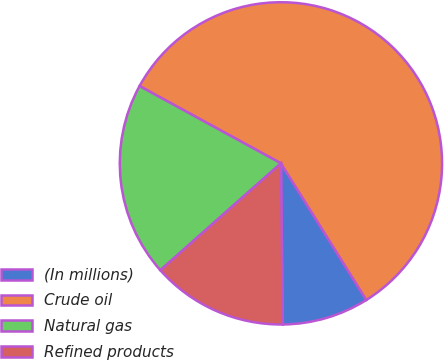Convert chart. <chart><loc_0><loc_0><loc_500><loc_500><pie_chart><fcel>(In millions)<fcel>Crude oil<fcel>Natural gas<fcel>Refined products<nl><fcel>8.7%<fcel>58.15%<fcel>19.5%<fcel>13.65%<nl></chart> 